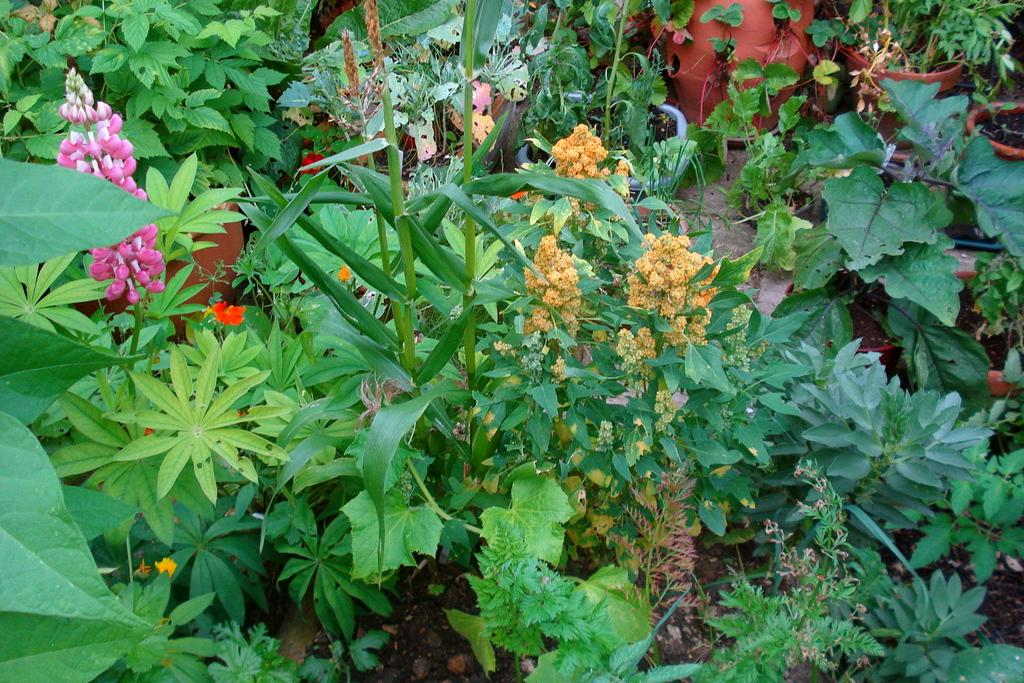What type of location is shown in the image? The image depicts a garden. What can be found in the garden? There are many plants in the garden. Can you describe the types of plants present in the garden? Some of the plants in the garden are flower plants. How many threads are visible in the image? There are no threads present in the image. What number represents the total count of plants in the garden? The number of plants in the garden cannot be determined from the image alone. 